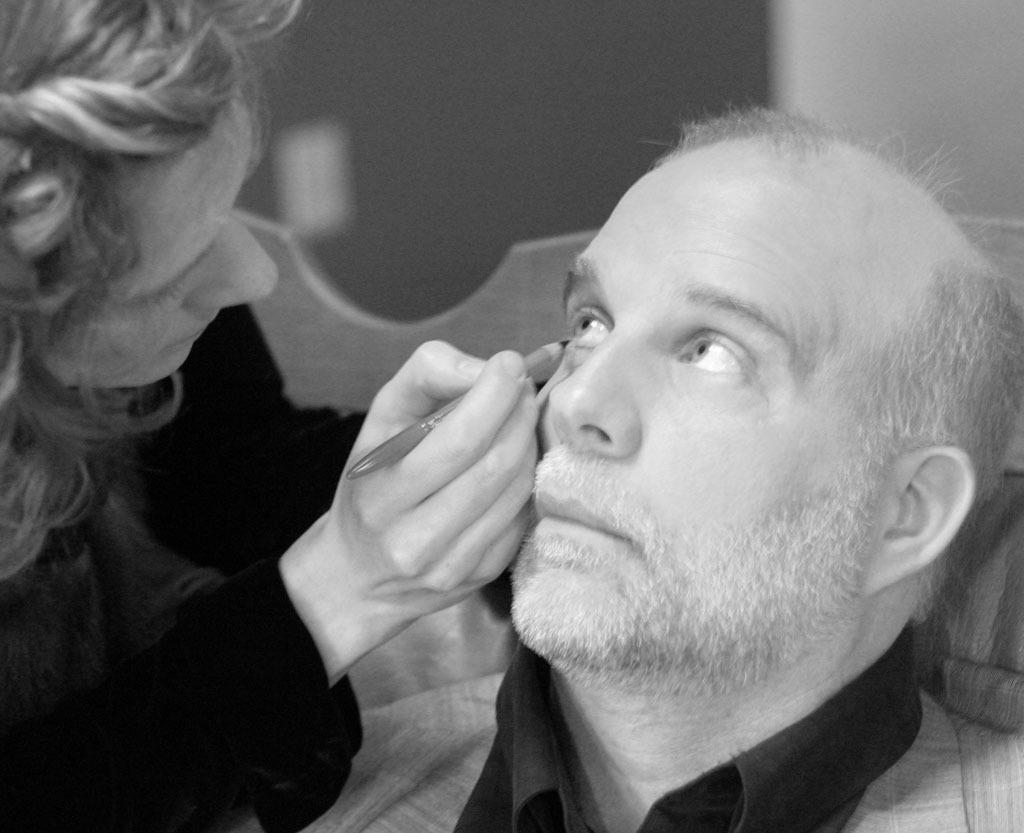What is the color scheme of the image? The image is black and white. Who is present in the image? There is a woman and a man in the image. What is the woman holding in her hand? The woman is holding a pen in her hand. What is the man doing in the image? The man is sitting on a chair. What is the woman doing with her eyes in the image? The woman's eyes are being focused on the man. How would you describe the background of the image? The background of the image is blurry. What type of quince is being used as a prop in the image? There is no quince present in the image; it is a black and white image featuring a woman and a man. 